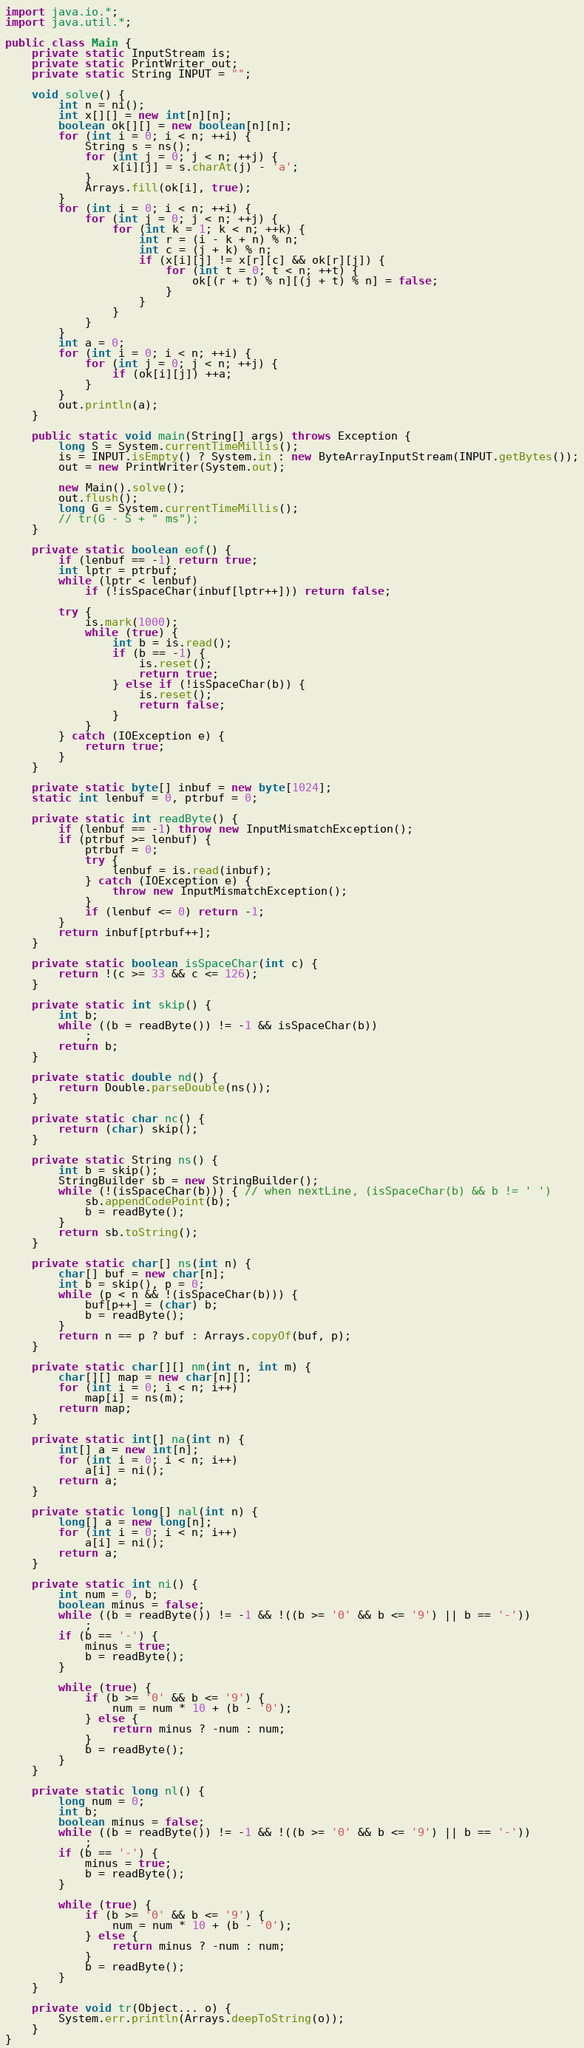Convert code to text. <code><loc_0><loc_0><loc_500><loc_500><_Java_>import java.io.*;
import java.util.*;

public class Main {
    private static InputStream is;
    private static PrintWriter out;
    private static String INPUT = "";

    void solve() {
        int n = ni();
        int x[][] = new int[n][n];
        boolean ok[][] = new boolean[n][n];
        for (int i = 0; i < n; ++i) {
            String s = ns();
            for (int j = 0; j < n; ++j) {
                x[i][j] = s.charAt(j) - 'a';
            }
            Arrays.fill(ok[i], true);
        }
        for (int i = 0; i < n; ++i) {
            for (int j = 0; j < n; ++j) {
                for (int k = 1; k < n; ++k) {
                    int r = (i - k + n) % n;
                    int c = (j + k) % n;
                    if (x[i][j] != x[r][c] && ok[r][j]) {
                        for (int t = 0; t < n; ++t) {
                            ok[(r + t) % n][(j + t) % n] = false;
                        }
                    }
                }
            }
        }
        int a = 0;
        for (int i = 0; i < n; ++i) {
            for (int j = 0; j < n; ++j) {
                if (ok[i][j]) ++a;
            }
        }
        out.println(a);
    }

    public static void main(String[] args) throws Exception {
        long S = System.currentTimeMillis();
        is = INPUT.isEmpty() ? System.in : new ByteArrayInputStream(INPUT.getBytes());
        out = new PrintWriter(System.out);

        new Main().solve();
        out.flush();
        long G = System.currentTimeMillis();
        // tr(G - S + " ms");
    }

    private static boolean eof() {
        if (lenbuf == -1) return true;
        int lptr = ptrbuf;
        while (lptr < lenbuf)
            if (!isSpaceChar(inbuf[lptr++])) return false;

        try {
            is.mark(1000);
            while (true) {
                int b = is.read();
                if (b == -1) {
                    is.reset();
                    return true;
                } else if (!isSpaceChar(b)) {
                    is.reset();
                    return false;
                }
            }
        } catch (IOException e) {
            return true;
        }
    }

    private static byte[] inbuf = new byte[1024];
    static int lenbuf = 0, ptrbuf = 0;

    private static int readByte() {
        if (lenbuf == -1) throw new InputMismatchException();
        if (ptrbuf >= lenbuf) {
            ptrbuf = 0;
            try {
                lenbuf = is.read(inbuf);
            } catch (IOException e) {
                throw new InputMismatchException();
            }
            if (lenbuf <= 0) return -1;
        }
        return inbuf[ptrbuf++];
    }

    private static boolean isSpaceChar(int c) {
        return !(c >= 33 && c <= 126);
    }

    private static int skip() {
        int b;
        while ((b = readByte()) != -1 && isSpaceChar(b))
            ;
        return b;
    }

    private static double nd() {
        return Double.parseDouble(ns());
    }

    private static char nc() {
        return (char) skip();
    }

    private static String ns() {
        int b = skip();
        StringBuilder sb = new StringBuilder();
        while (!(isSpaceChar(b))) { // when nextLine, (isSpaceChar(b) && b != ' ')
            sb.appendCodePoint(b);
            b = readByte();
        }
        return sb.toString();
    }

    private static char[] ns(int n) {
        char[] buf = new char[n];
        int b = skip(), p = 0;
        while (p < n && !(isSpaceChar(b))) {
            buf[p++] = (char) b;
            b = readByte();
        }
        return n == p ? buf : Arrays.copyOf(buf, p);
    }

    private static char[][] nm(int n, int m) {
        char[][] map = new char[n][];
        for (int i = 0; i < n; i++)
            map[i] = ns(m);
        return map;
    }

    private static int[] na(int n) {
        int[] a = new int[n];
        for (int i = 0; i < n; i++)
            a[i] = ni();
        return a;
    }

    private static long[] nal(int n) {
        long[] a = new long[n];
        for (int i = 0; i < n; i++)
            a[i] = ni();
        return a;
    }

    private static int ni() {
        int num = 0, b;
        boolean minus = false;
        while ((b = readByte()) != -1 && !((b >= '0' && b <= '9') || b == '-'))
            ;
        if (b == '-') {
            minus = true;
            b = readByte();
        }

        while (true) {
            if (b >= '0' && b <= '9') {
                num = num * 10 + (b - '0');
            } else {
                return minus ? -num : num;
            }
            b = readByte();
        }
    }

    private static long nl() {
        long num = 0;
        int b;
        boolean minus = false;
        while ((b = readByte()) != -1 && !((b >= '0' && b <= '9') || b == '-'))
            ;
        if (b == '-') {
            minus = true;
            b = readByte();
        }

        while (true) {
            if (b >= '0' && b <= '9') {
                num = num * 10 + (b - '0');
            } else {
                return minus ? -num : num;
            }
            b = readByte();
        }
    }

    private void tr(Object... o) {
        System.err.println(Arrays.deepToString(o));
    }
}</code> 